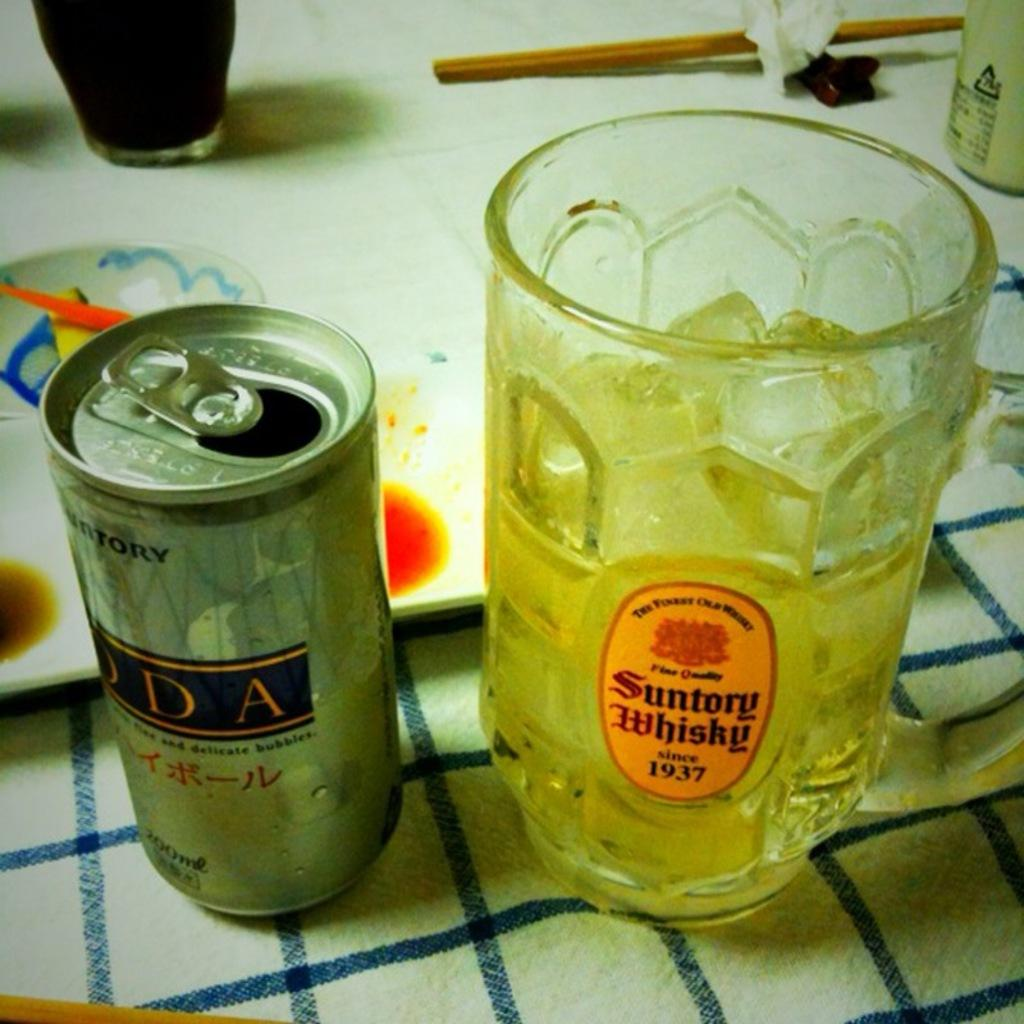<image>
Share a concise interpretation of the image provided. A mug that says Suntory Whisky has the date 1937 on it. 